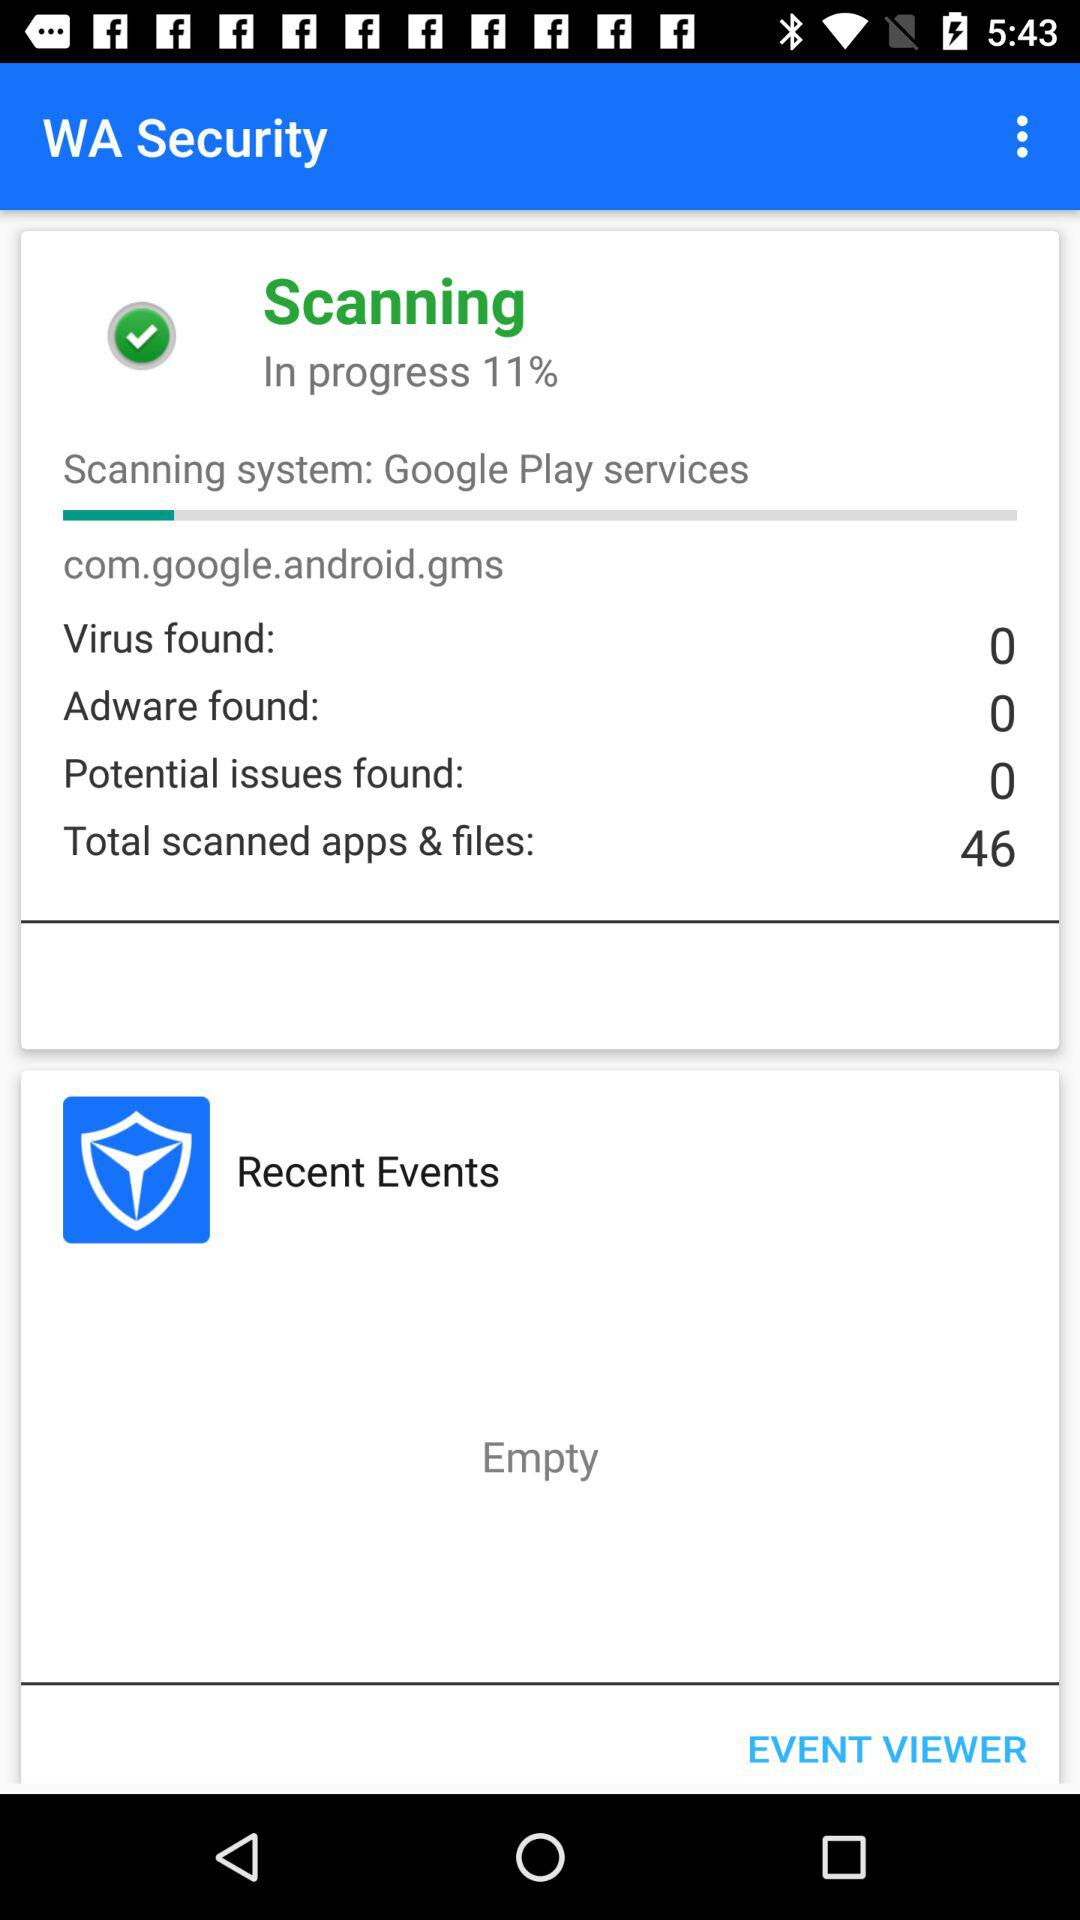What is the count of total scanned apps and files? The count of total scanned apps and files is 46. 